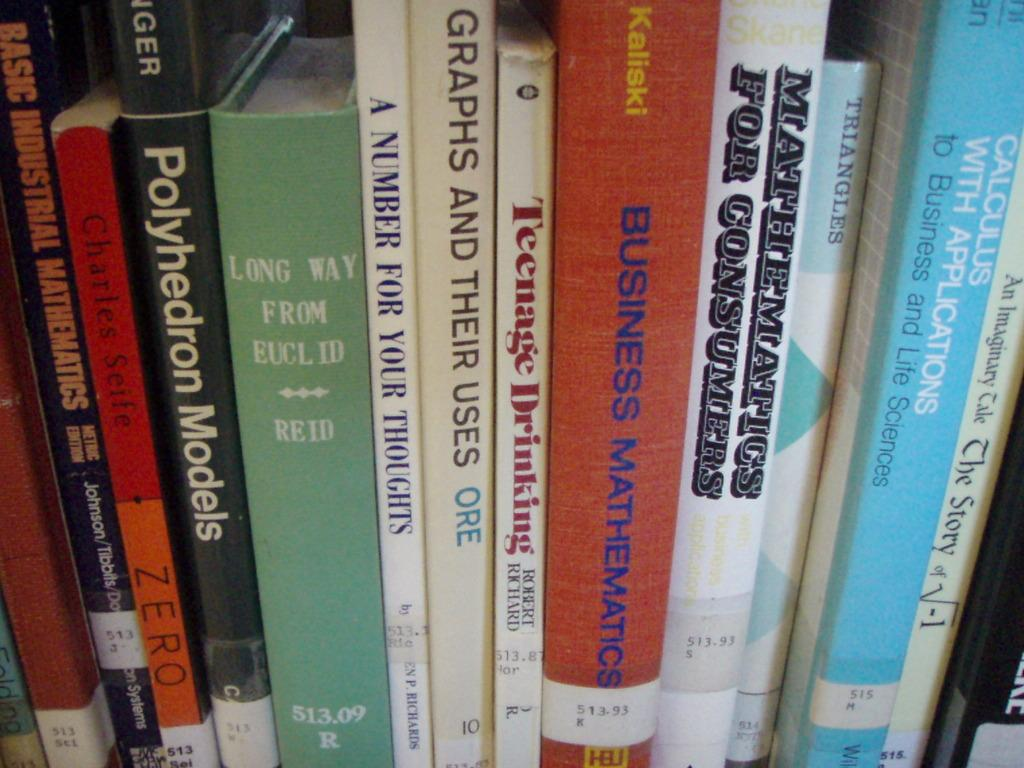<image>
Render a clear and concise summary of the photo. Red book titled Business Mathematics in between other books on a shelf. 